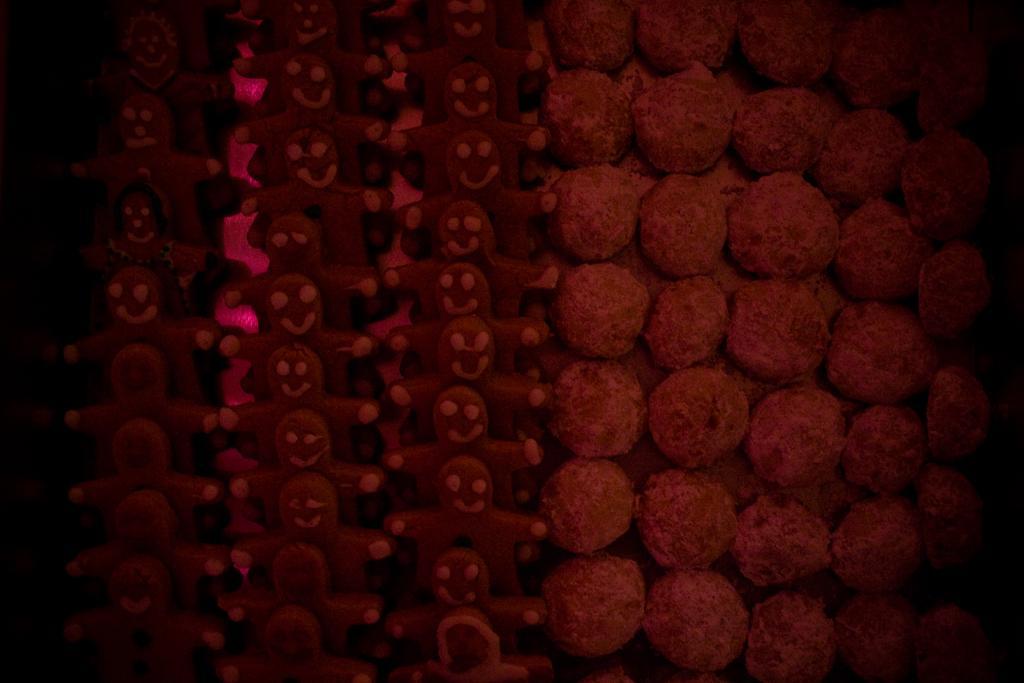How would you summarize this image in a sentence or two? In the picture we can see a cookies, which are doll shape and brown in color and placed in the sequence and beside it also we can see some cookies which are brown in color and placed in the sequence. 